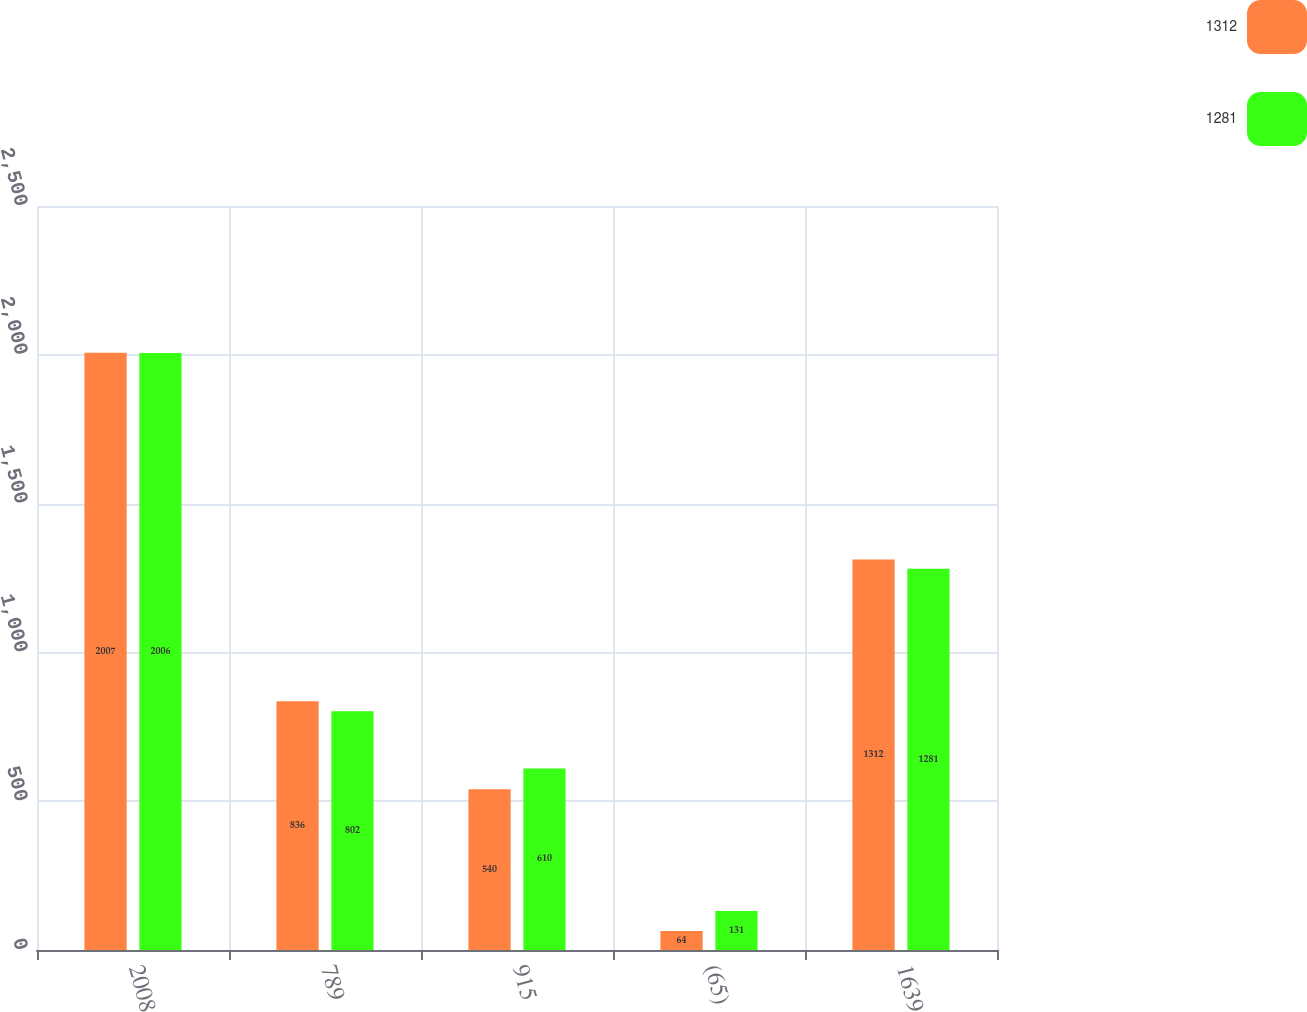<chart> <loc_0><loc_0><loc_500><loc_500><stacked_bar_chart><ecel><fcel>2008<fcel>789<fcel>915<fcel>(65)<fcel>1639<nl><fcel>1312<fcel>2007<fcel>836<fcel>540<fcel>64<fcel>1312<nl><fcel>1281<fcel>2006<fcel>802<fcel>610<fcel>131<fcel>1281<nl></chart> 